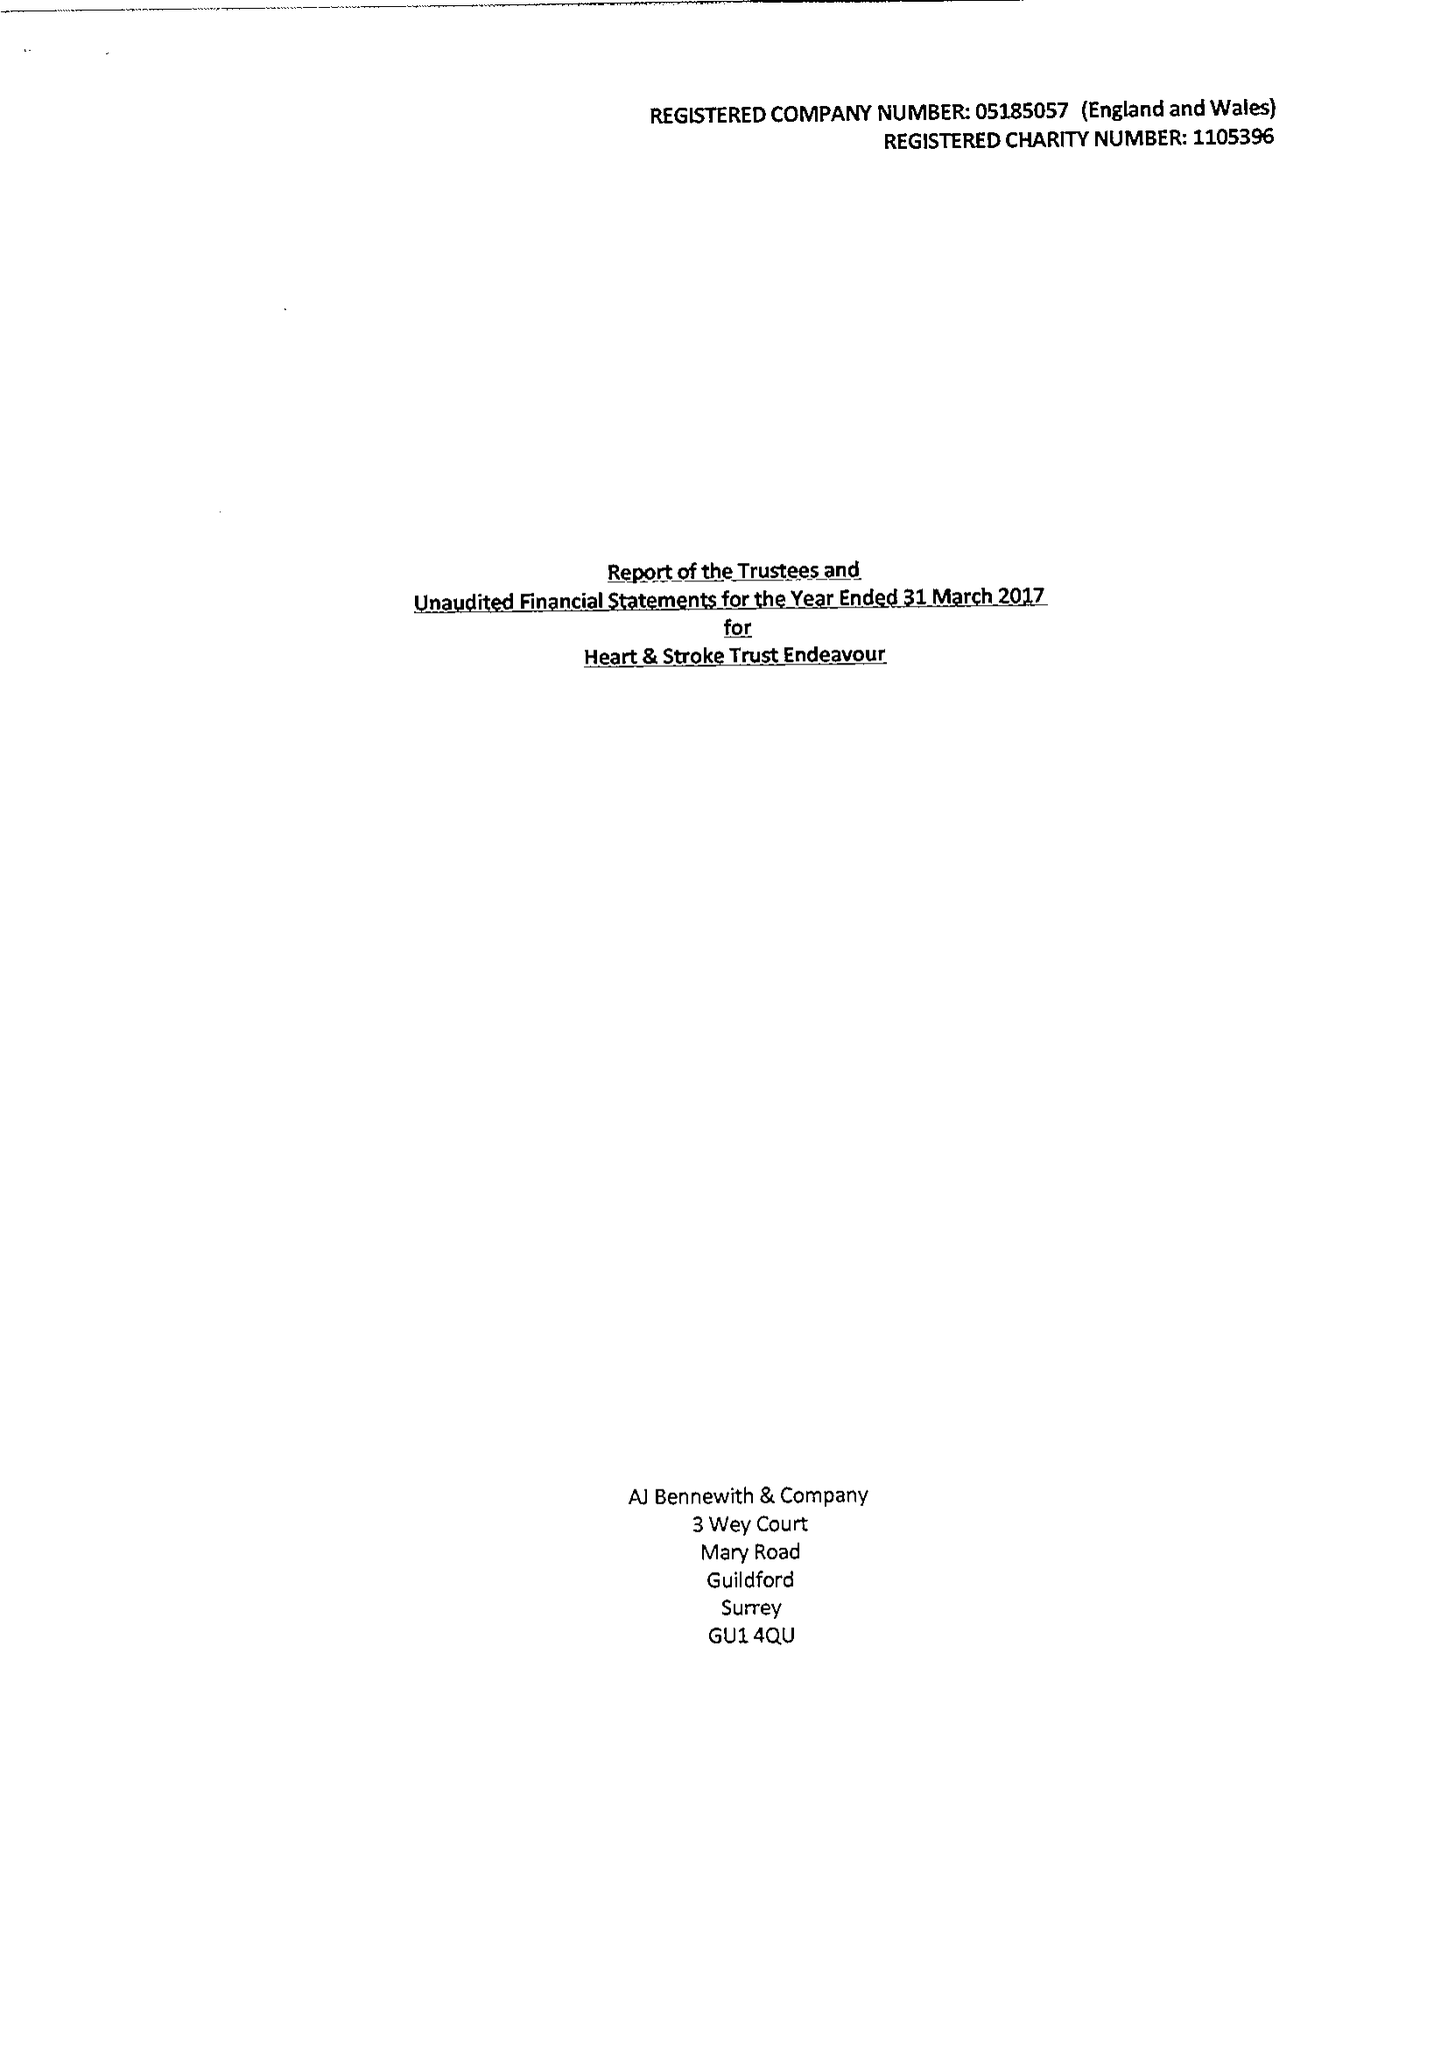What is the value for the address__post_town?
Answer the question using a single word or phrase. GUILDFORD 